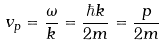<formula> <loc_0><loc_0><loc_500><loc_500>v _ { p } = { \frac { \omega } { k } } = { \frac { \hbar { k } } { 2 m } } = { \frac { p } { 2 m } }</formula> 